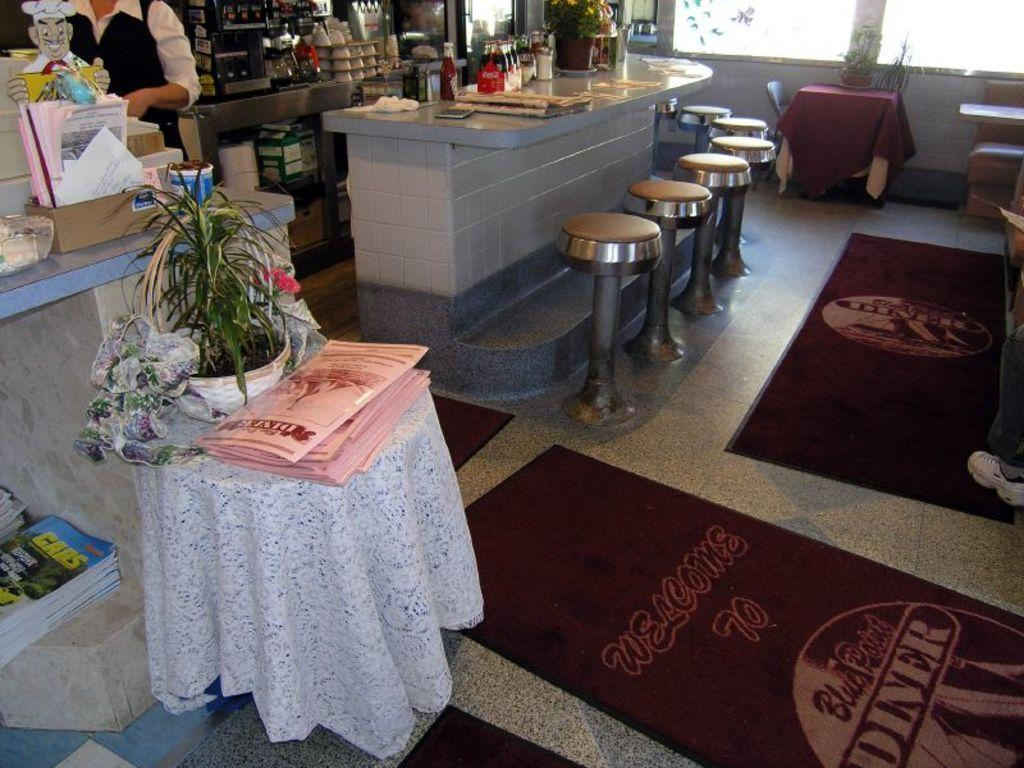Who or what is present in the image? There is a person in the image. What type of furniture is visible in the image? There are stools and a chair in the image. What can be seen on the counter tops in the image? There are things on the counter tops in the image. What type of surface is present in the image? There is a table in the image. What type of vegetation is present in the image? There are plants in the image. What type of bean is being processed in the industry depicted in the image? There is no industry or bean present in the image; it features a person, furniture, counter tops, and plants. What facial expression does the person have in the image? The provided facts do not mention the person's facial expression, so it cannot be determined from the image. 